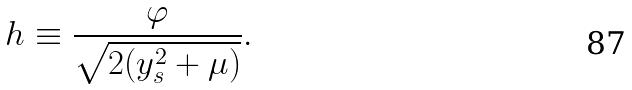Convert formula to latex. <formula><loc_0><loc_0><loc_500><loc_500>h \equiv \frac { \varphi } { \sqrt { 2 ( y ^ { 2 } _ { s } + \mu ) } } .</formula> 